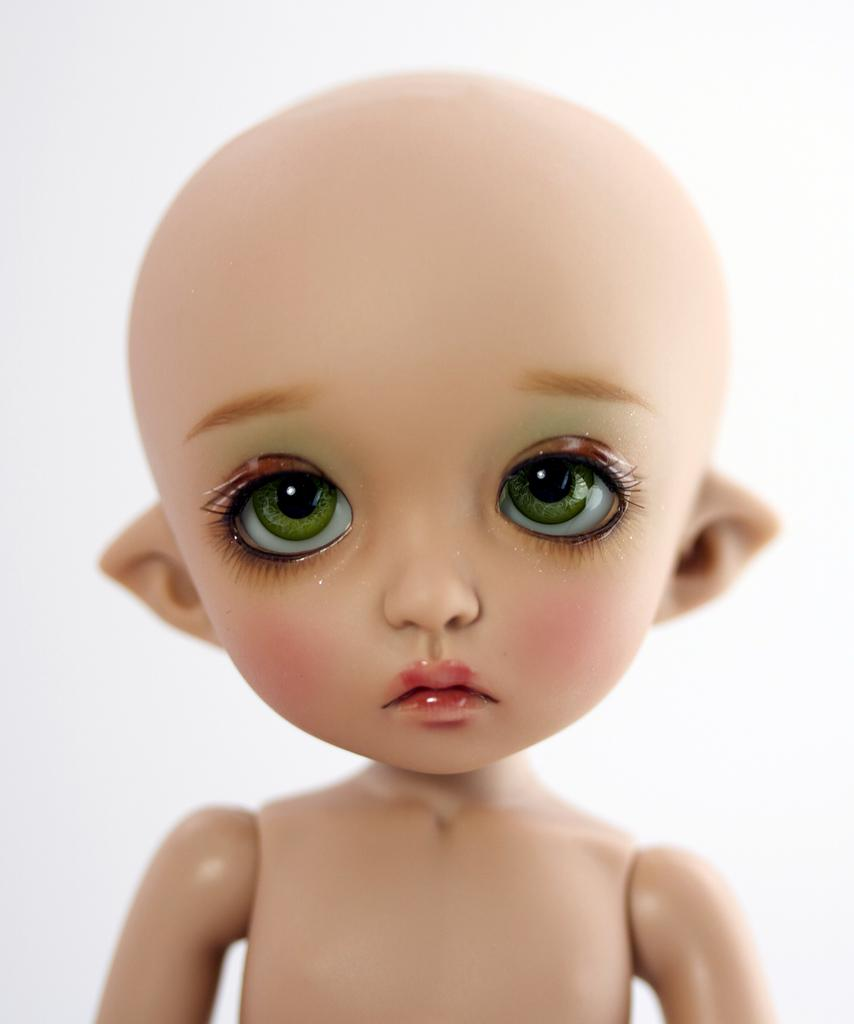What is the main subject of the image? There is a depiction of a baby in the image. What color is the background of the image? The background of the image is white. Can you tell me how the baby is pulling the vase in the image? There is no vase present in the image, and therefore no such action can be observed. 